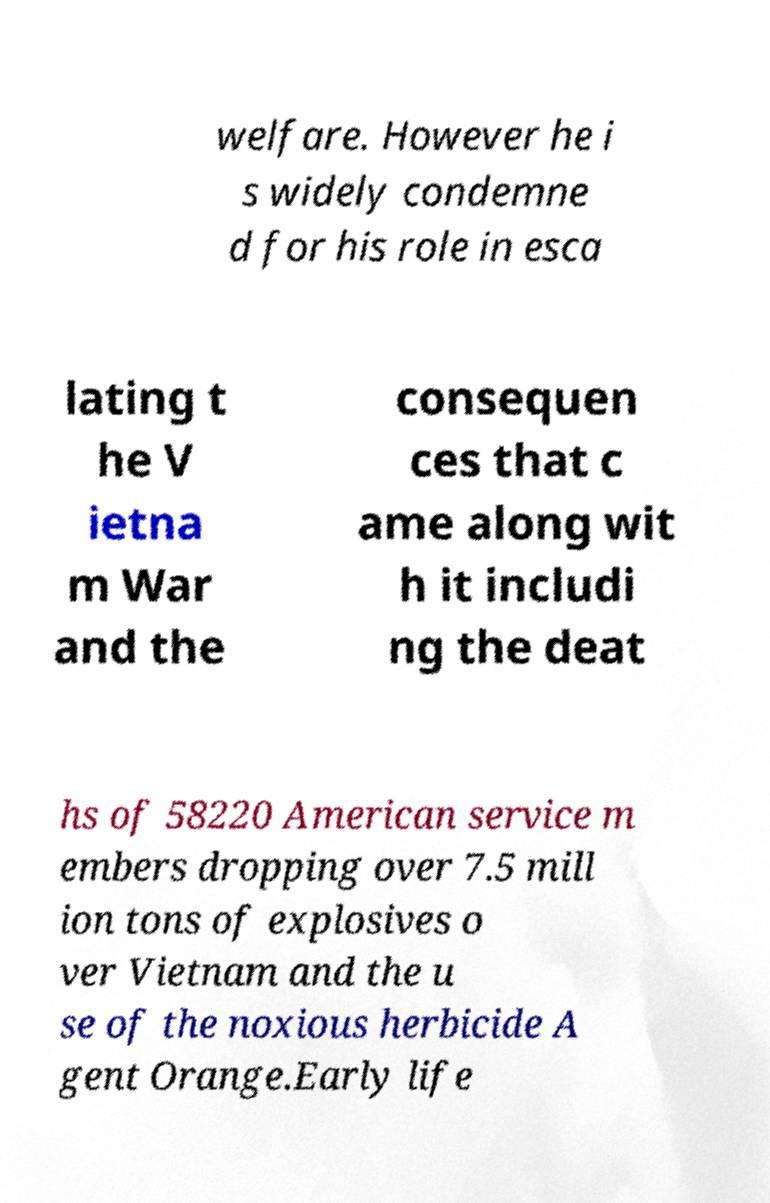Could you assist in decoding the text presented in this image and type it out clearly? welfare. However he i s widely condemne d for his role in esca lating t he V ietna m War and the consequen ces that c ame along wit h it includi ng the deat hs of 58220 American service m embers dropping over 7.5 mill ion tons of explosives o ver Vietnam and the u se of the noxious herbicide A gent Orange.Early life 